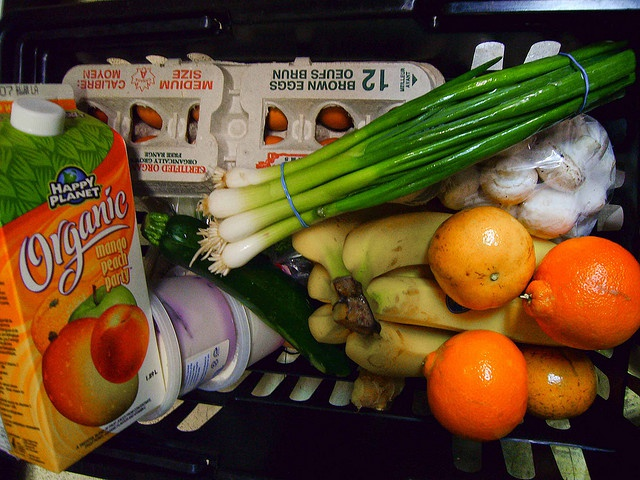Describe the objects in this image and their specific colors. I can see banana in darkgray, olive, and black tones, orange in darkgray, red, and maroon tones, orange in darkgray, red, brown, and maroon tones, orange in darkgray, orange, and brown tones, and orange in darkgray, brown, maroon, red, and black tones in this image. 